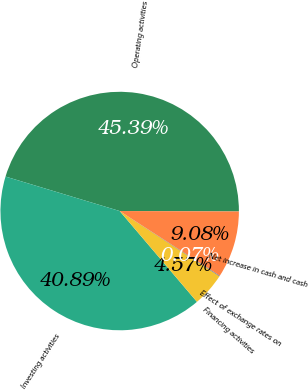<chart> <loc_0><loc_0><loc_500><loc_500><pie_chart><fcel>Operating activities<fcel>Investing activities<fcel>Financing activities<fcel>Effect of exchange rates on<fcel>Net increase in cash and cash<nl><fcel>45.39%<fcel>40.89%<fcel>4.57%<fcel>0.07%<fcel>9.08%<nl></chart> 